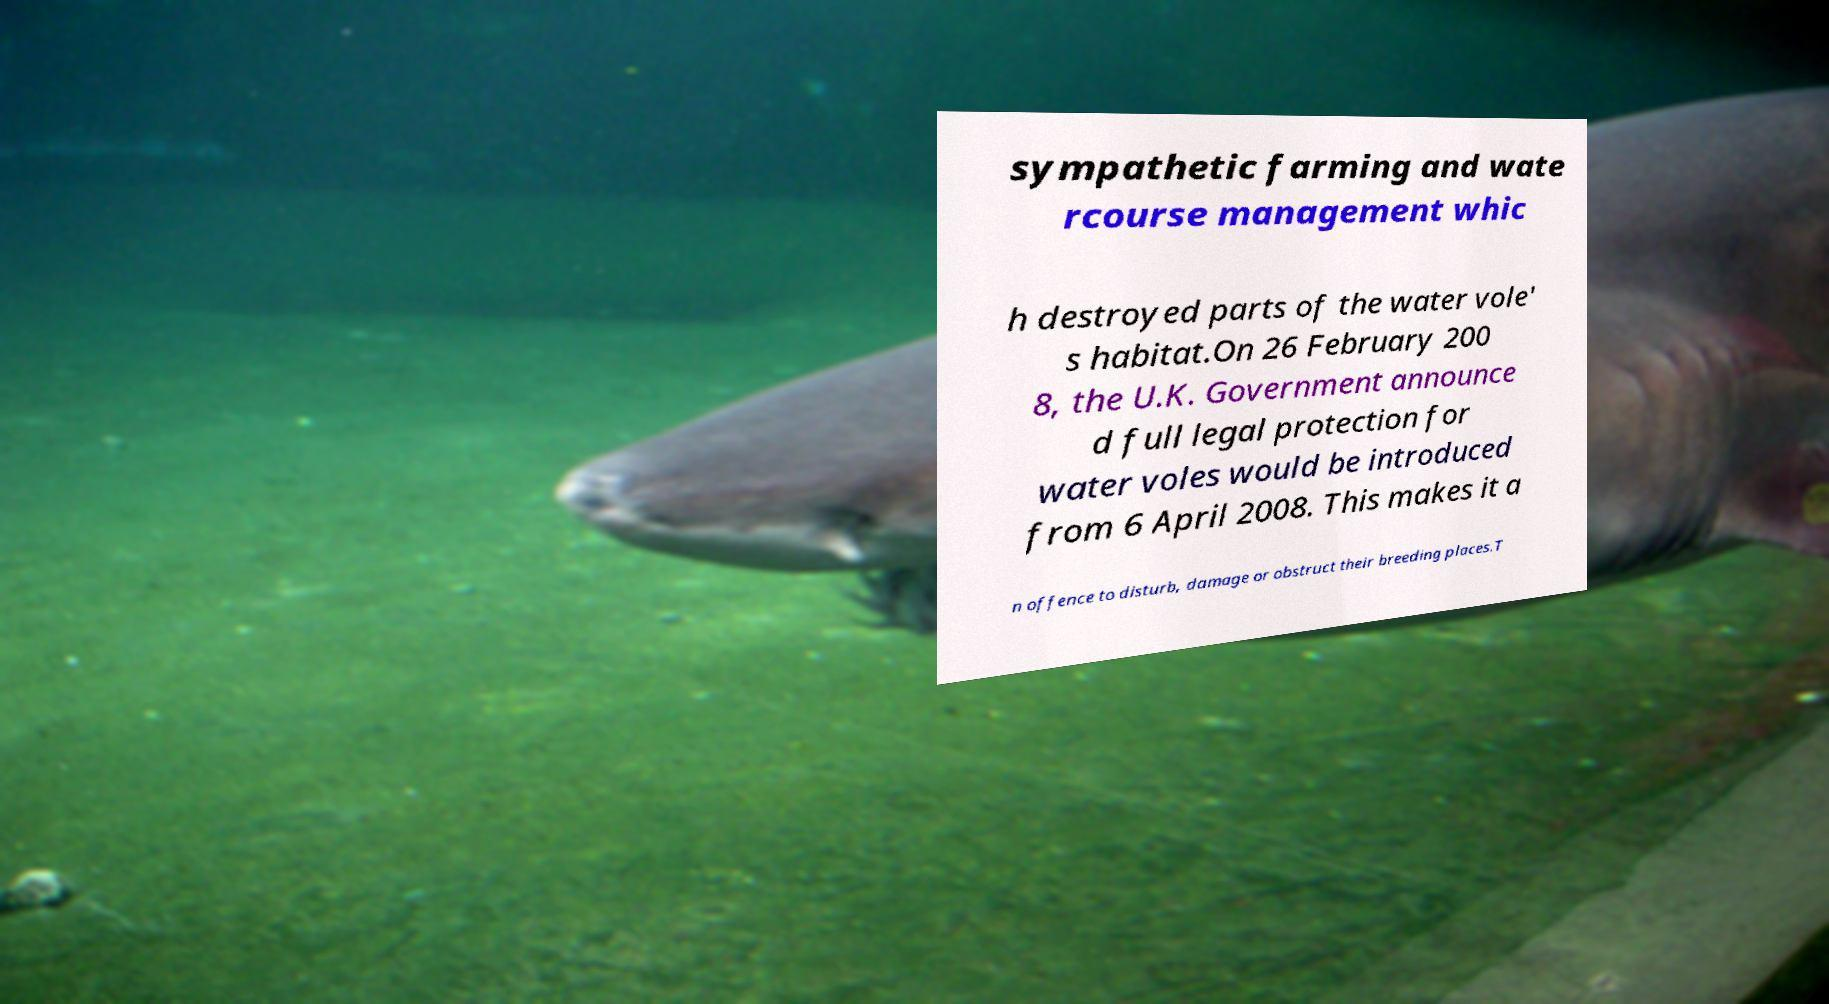Could you extract and type out the text from this image? sympathetic farming and wate rcourse management whic h destroyed parts of the water vole' s habitat.On 26 February 200 8, the U.K. Government announce d full legal protection for water voles would be introduced from 6 April 2008. This makes it a n offence to disturb, damage or obstruct their breeding places.T 